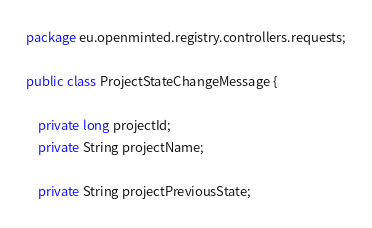Convert code to text. <code><loc_0><loc_0><loc_500><loc_500><_Java_>package eu.openminted.registry.controllers.requests;

public class ProjectStateChangeMessage {

    private long projectId;
    private String projectName;

    private String projectPreviousState;</code> 